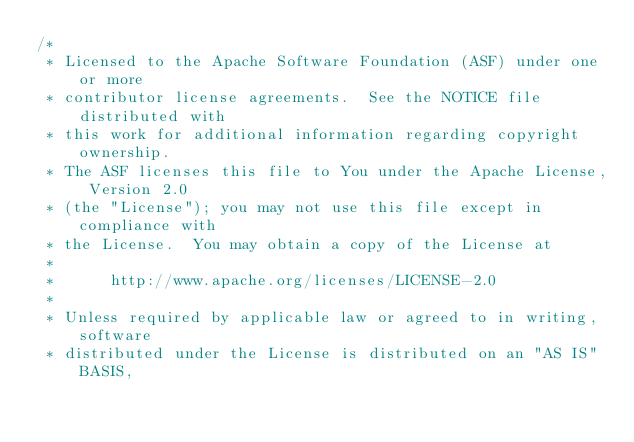Convert code to text. <code><loc_0><loc_0><loc_500><loc_500><_C++_>/*
 * Licensed to the Apache Software Foundation (ASF) under one or more
 * contributor license agreements.  See the NOTICE file distributed with
 * this work for additional information regarding copyright ownership.
 * The ASF licenses this file to You under the Apache License, Version 2.0
 * (the "License"); you may not use this file except in compliance with
 * the License.  You may obtain a copy of the License at
 *
 *      http://www.apache.org/licenses/LICENSE-2.0
 *
 * Unless required by applicable law or agreed to in writing, software
 * distributed under the License is distributed on an "AS IS" BASIS,</code> 